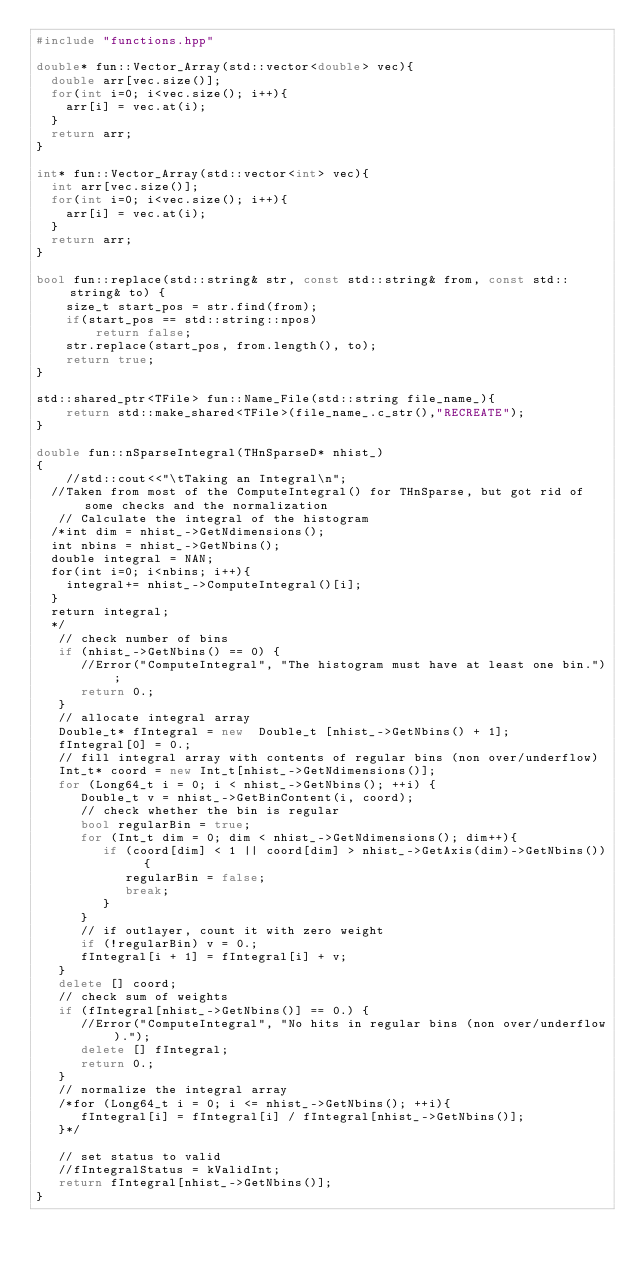<code> <loc_0><loc_0><loc_500><loc_500><_C++_>#include "functions.hpp"

double* fun::Vector_Array(std::vector<double> vec){
	double arr[vec.size()];
	for(int i=0; i<vec.size(); i++){
		arr[i] = vec.at(i);
	}
	return arr;
}

int* fun::Vector_Array(std::vector<int> vec){
	int arr[vec.size()];
	for(int i=0; i<vec.size(); i++){
		arr[i] = vec.at(i);
	}
	return arr;
}

bool fun::replace(std::string& str, const std::string& from, const std::string& to) {
    size_t start_pos = str.find(from);
    if(start_pos == std::string::npos)
        return false;
    str.replace(start_pos, from.length(), to);
    return true;
}

std::shared_ptr<TFile> fun::Name_File(std::string file_name_){
    return std::make_shared<TFile>(file_name_.c_str(),"RECREATE");
}

double fun::nSparseIntegral(THnSparseD* nhist_)
{
    //std::cout<<"\tTaking an Integral\n";
  //Taken from most of the ComputeIntegral() for THnSparse, but got rid of some checks and the normalization
   // Calculate the integral of the histogram
  /*int dim = nhist_->GetNdimensions();
  int nbins = nhist_->GetNbins();
  double integral = NAN;
  for(int i=0; i<nbins; i++){
    integral+= nhist_->ComputeIntegral()[i];
  }
  return integral;
  */
   // check number of bins
   if (nhist_->GetNbins() == 0) {
      //Error("ComputeIntegral", "The histogram must have at least one bin.");
      return 0.;
   }
   // allocate integral array
   Double_t* fIntegral = new  Double_t [nhist_->GetNbins() + 1];
   fIntegral[0] = 0.;
   // fill integral array with contents of regular bins (non over/underflow)
   Int_t* coord = new Int_t[nhist_->GetNdimensions()];
   for (Long64_t i = 0; i < nhist_->GetNbins(); ++i) {
      Double_t v = nhist_->GetBinContent(i, coord);
      // check whether the bin is regular
      bool regularBin = true;
      for (Int_t dim = 0; dim < nhist_->GetNdimensions(); dim++){
         if (coord[dim] < 1 || coord[dim] > nhist_->GetAxis(dim)->GetNbins()) {
            regularBin = false;
            break;
         }
      }
      // if outlayer, count it with zero weight
      if (!regularBin) v = 0.;
      fIntegral[i + 1] = fIntegral[i] + v;
   }
   delete [] coord;
   // check sum of weights
   if (fIntegral[nhist_->GetNbins()] == 0.) {
      //Error("ComputeIntegral", "No hits in regular bins (non over/underflow).");
      delete [] fIntegral;
      return 0.;
   }
   // normalize the integral array
   /*for (Long64_t i = 0; i <= nhist_->GetNbins(); ++i){
      fIntegral[i] = fIntegral[i] / fIntegral[nhist_->GetNbins()];
   }*/

   // set status to valid
   //fIntegralStatus = kValidInt;
   return fIntegral[nhist_->GetNbins()];
}
</code> 